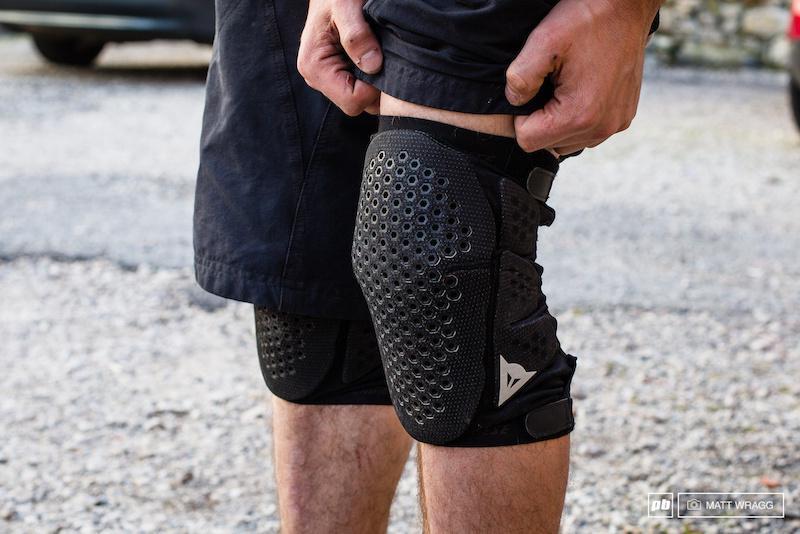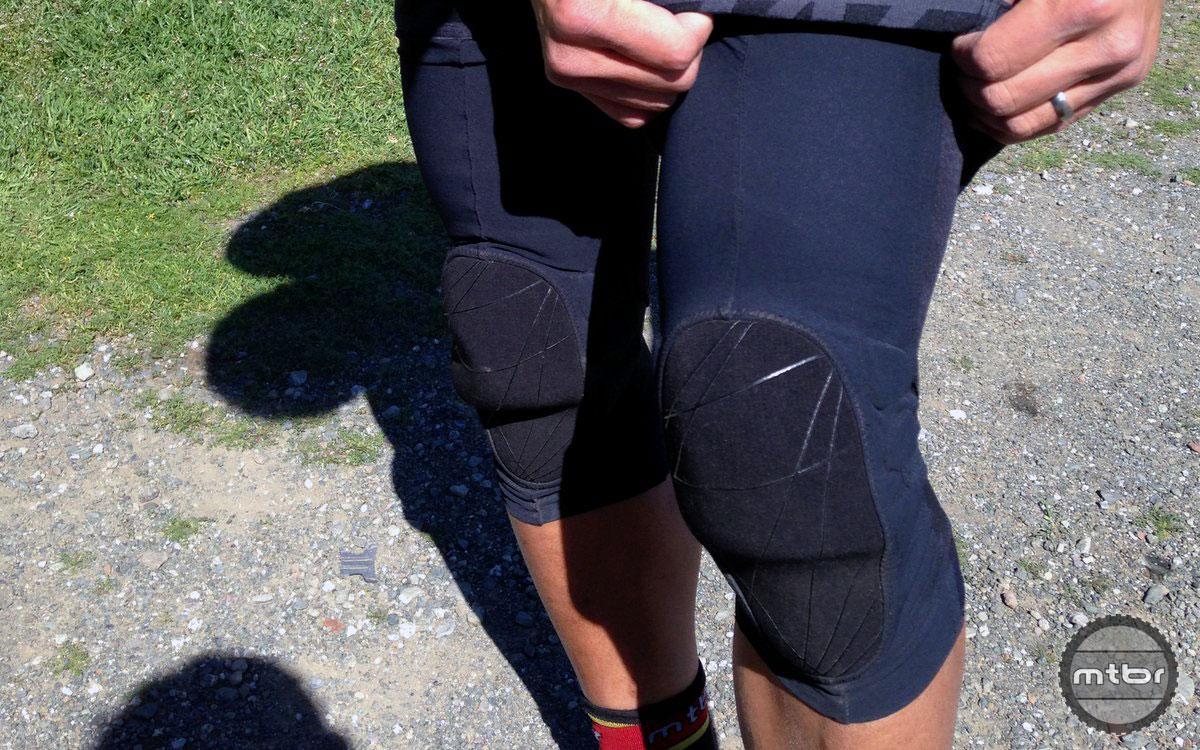The first image is the image on the left, the second image is the image on the right. Evaluate the accuracy of this statement regarding the images: "Product is shown not on a body.". Is it true? Answer yes or no. No. 